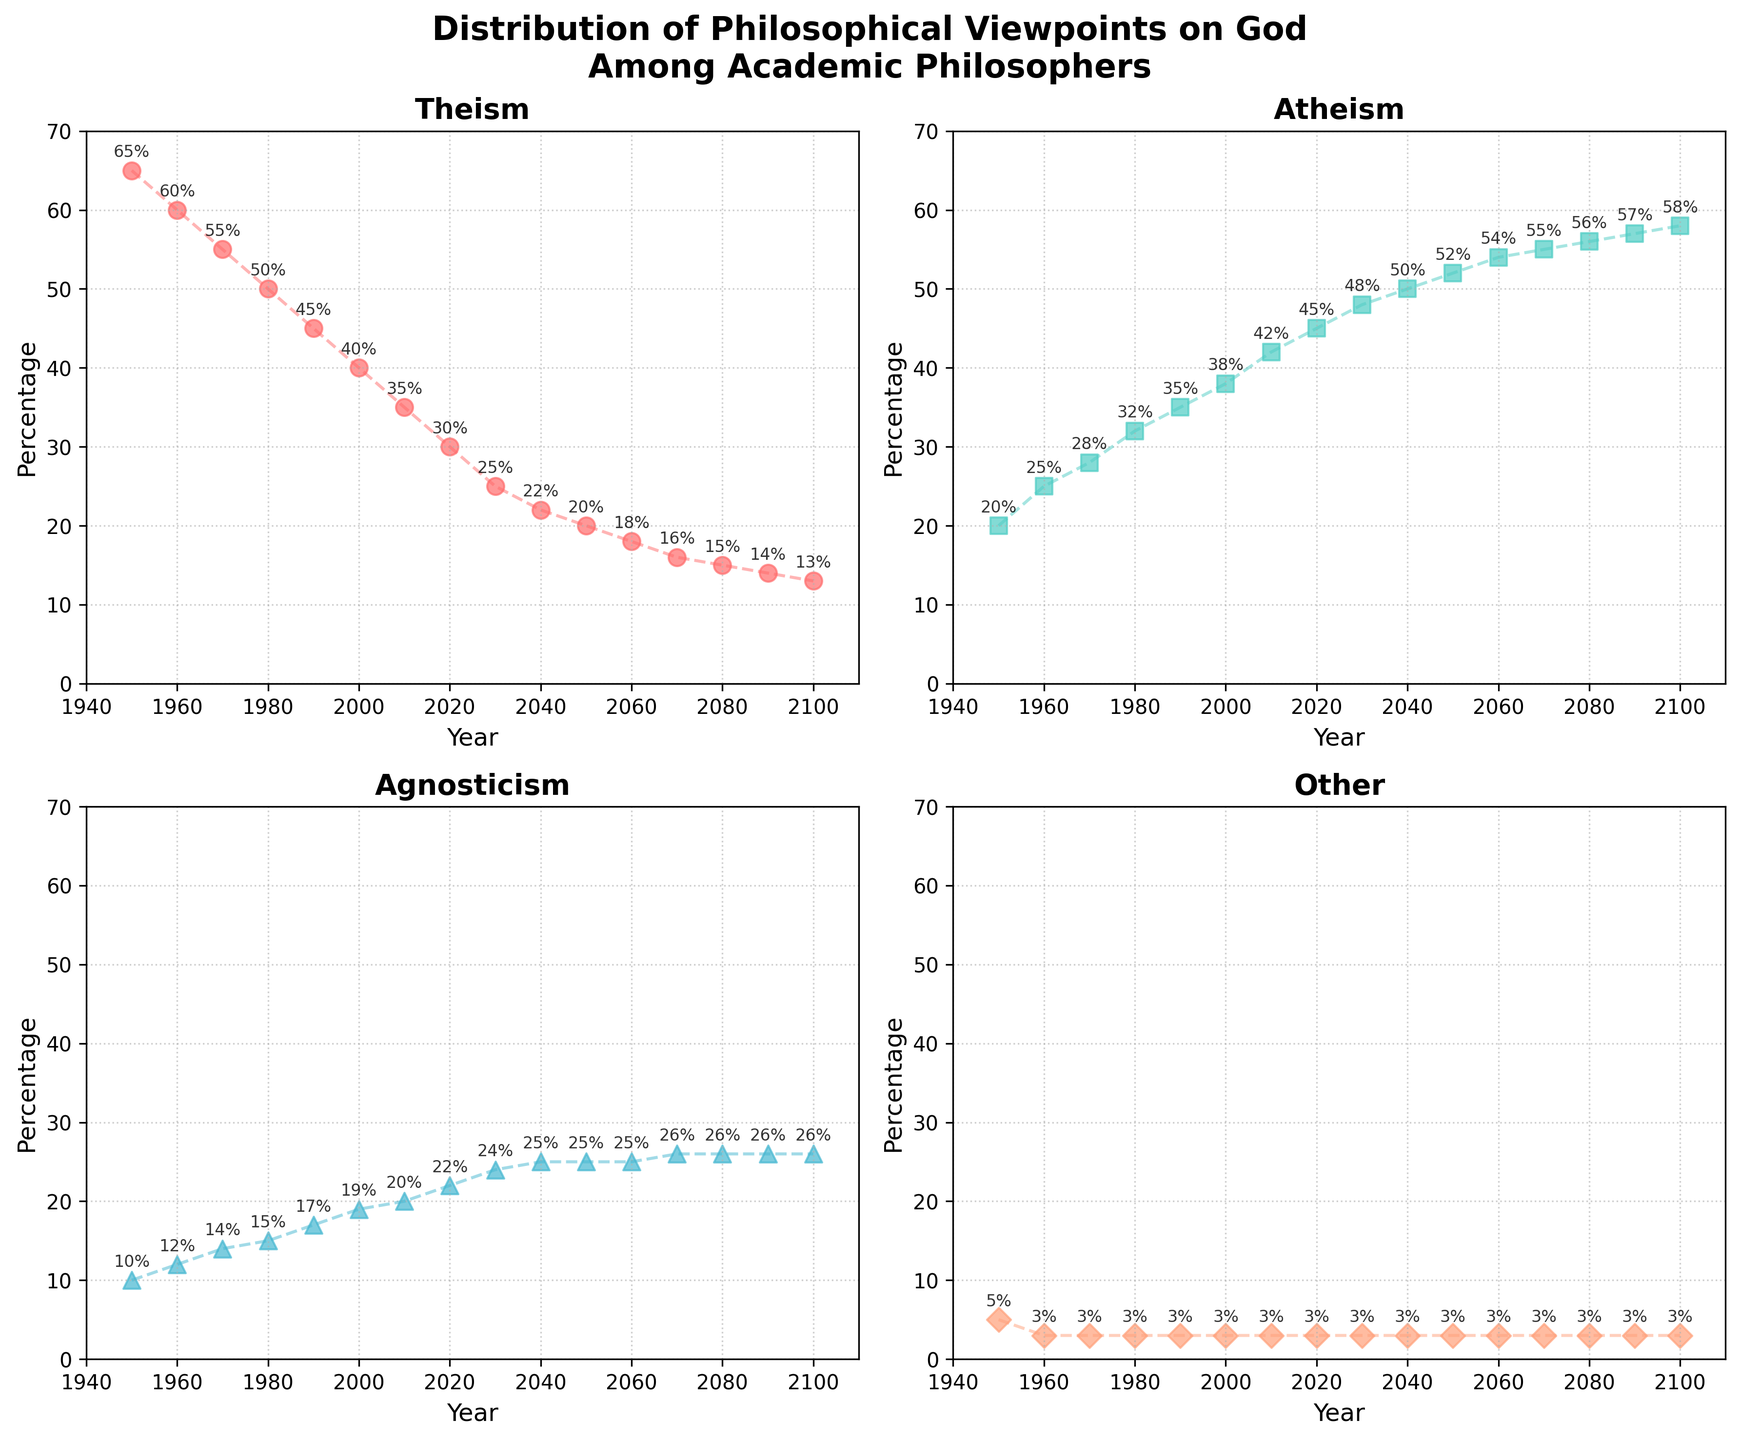what's the trend in the percentage of academic philosophers identifying as theists from 1950 to 2100? The theism subplot shows a general decrease in the percentage of theists over time. The scatter plot and the line plot indicate that the percentage has decreased steadily from about 65% in 1950 to about 13% in 2100.
Answer: Decreasing how does the percentage of atheists in 2060 compare to the percentage of agnostics in the same year? In 2060, the scatter plot for atheism shows about 54%, while the scatter plot for agnosticism shows about 25%. Atheism has a significantly higher percentage than agnosticism in 2060.
Answer: Atheism is higher what is the combined percentage of agnosticism and theism in 2020? The scatter plots for agnosticism and theism in 2020 show approximately 22% and 30%, respectively. Summing these values gives a combined percentage of 52%.
Answer: 52% between which two consecutive decades does the steepest decline in theism occur? By observing the theism subplot, the steepest decline seems to occur between 1950 and 1960, where the percentage drops from around 65% to 60%. The gradient of the line plot during this decade is sharper compared to others.
Answer: 1950-1960 what is the maximum percentage reached by atheism during the noted years, and in which year does it occur? The scatter plot for atheism shows that it reaches its maximum percentage of approximately 58% in the year 2100.
Answer: 58% in 2100 compare the initial and final percentages of people identifying with the 'Other' category. What is the difference? The scatter plots and line plots for the "Other" category show that the percentage starts at 5% in 1950 and remains relatively constant at 3% by 2100. The difference between the initial and final percentages is 2%.
Answer: 2% what is the general trend of agnosticism from 1950 to 2100, and is there any noticeable fluctuation? The agnosticism subplot indicates a generally increasing trend from 1950 to 2100, starting at about 10% and rising to approximately 26%. There is a steady increase without noticeable fluctuations.
Answer: Increasing, no noticeable fluctuation in the year 2000, what percentage of academic philosophers identified neither as atheists nor theists, and how is this percentage distributed among other categories? In 2000, atheists were about 38% and theists were about 40%, making a total of 78%. The remaining 22% is divided into agnosticism (~19%) and other categories (~3%).
Answer: 22% (19% agnosticism, 3% other) how does the percentage of agnostics in 2080 compare to the percentage of theists in the same year? In 2080, the scatter plot for agnosticism shows about 26%, while the scatter plot for theism shows about 15%. The percentage of agnostics is significantly higher than that of theists.
Answer: Agnosticism is higher which viewpoint category shows the least change over time? By comparing the trend lines and scatter plots across all subplots, the "Other" category shows the least change, maintaining a relatively stable percentage around 3%-5% from 1950 to 2100.
Answer: Other 